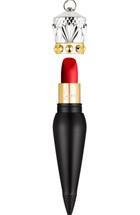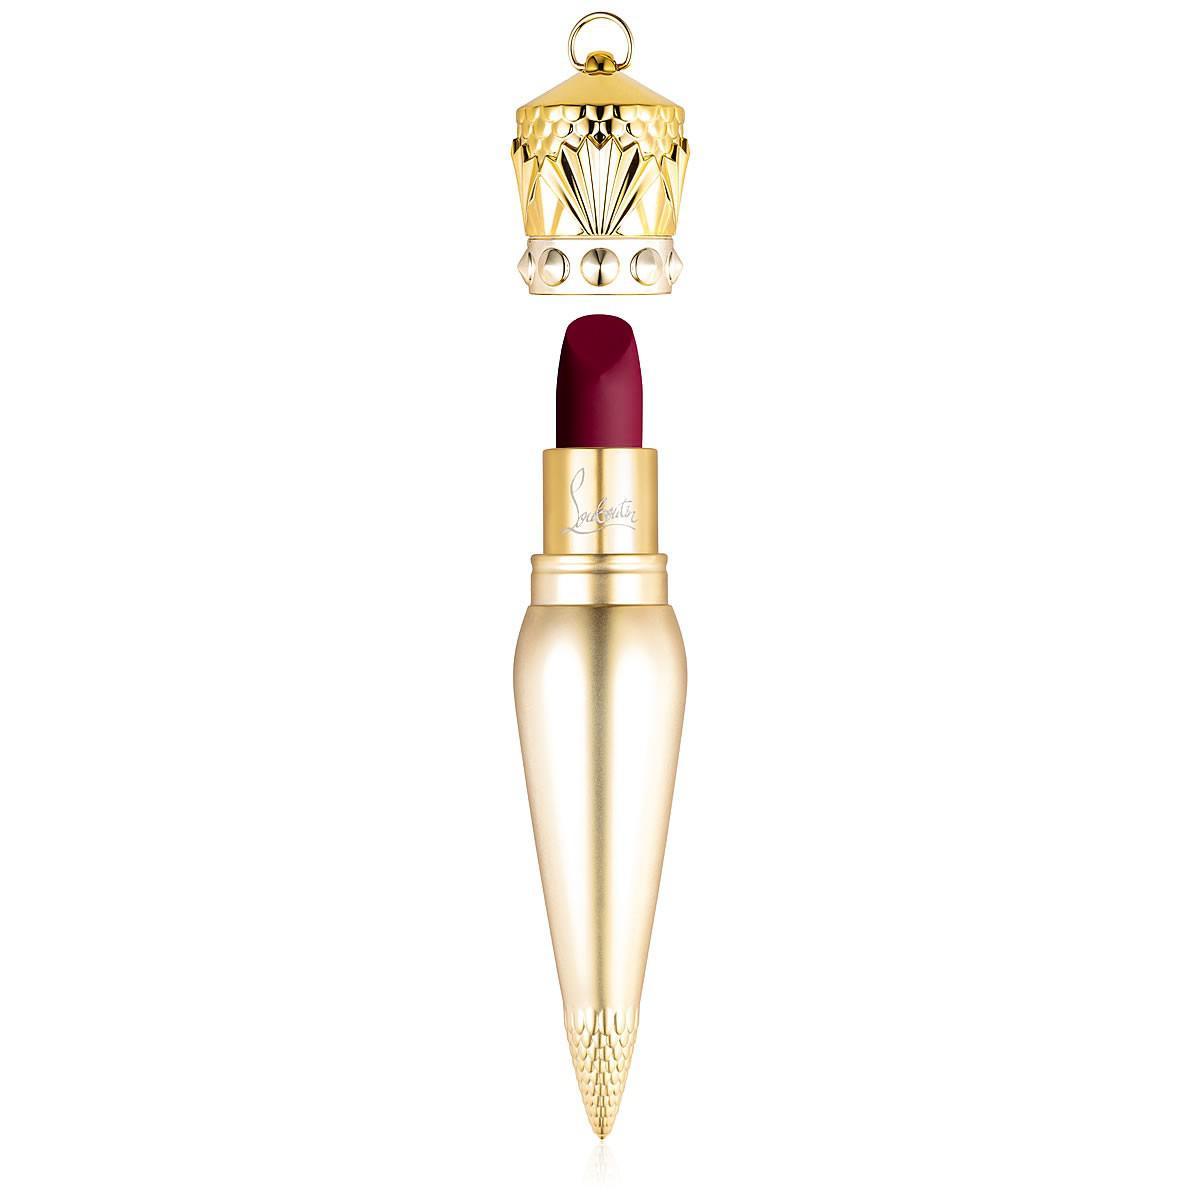The first image is the image on the left, the second image is the image on the right. For the images shown, is this caption "There are 2 lipstick pencils crossed neatly like an X and one has the cap off." true? Answer yes or no. No. The first image is the image on the left, the second image is the image on the right. For the images displayed, is the sentence "In one of the photos, there are two sticks of lipstick crossing each other." factually correct? Answer yes or no. No. 